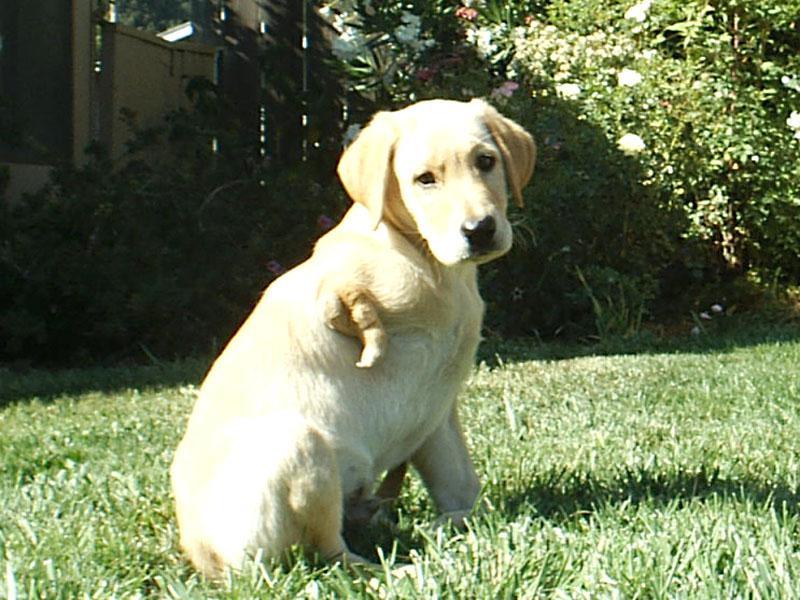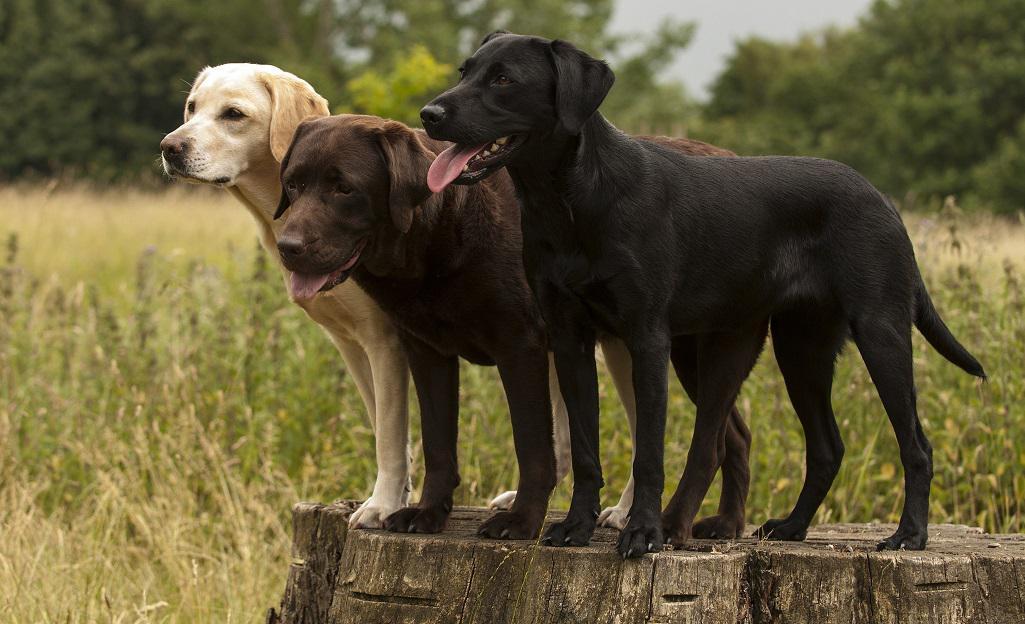The first image is the image on the left, the second image is the image on the right. Considering the images on both sides, is "One image features one dog that is missing a front limb, and the other image contains at least twice as many dogs." valid? Answer yes or no. Yes. The first image is the image on the left, the second image is the image on the right. For the images shown, is this caption "One of the dogs is missing a front leg." true? Answer yes or no. Yes. 